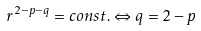Convert formula to latex. <formula><loc_0><loc_0><loc_500><loc_500>r ^ { 2 - p - q } = c o n s t . \Leftrightarrow q = 2 - p</formula> 